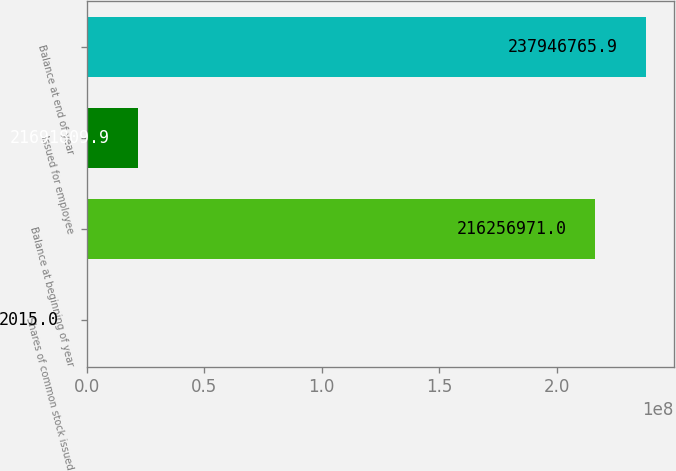Convert chart to OTSL. <chart><loc_0><loc_0><loc_500><loc_500><bar_chart><fcel>Shares of common stock issued<fcel>Balance at beginning of year<fcel>Issued for employee<fcel>Balance at end of year<nl><fcel>2015<fcel>2.16257e+08<fcel>2.16918e+07<fcel>2.37947e+08<nl></chart> 